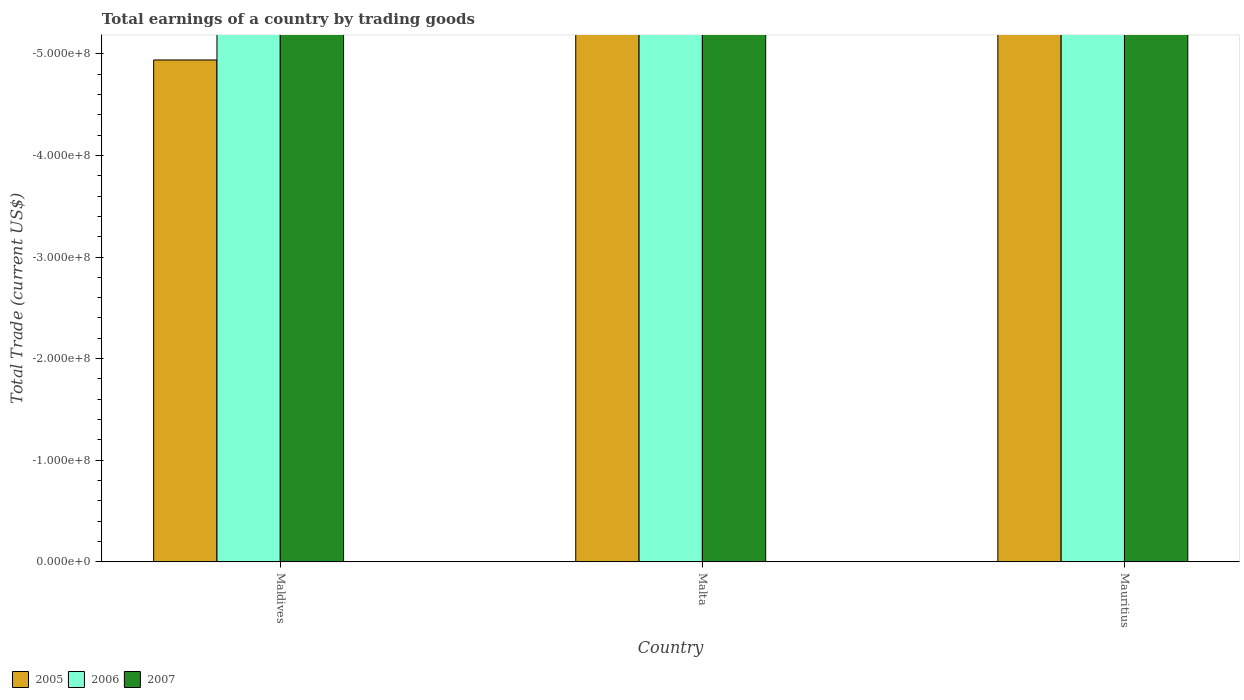Are the number of bars per tick equal to the number of legend labels?
Offer a very short reply. No. Are the number of bars on each tick of the X-axis equal?
Offer a terse response. Yes. What is the label of the 2nd group of bars from the left?
Ensure brevity in your answer.  Malta. What is the total earnings in 2005 in Malta?
Your response must be concise. 0. What is the total total earnings in 2005 in the graph?
Your response must be concise. 0. What is the average total earnings in 2006 per country?
Offer a very short reply. 0. In how many countries, is the total earnings in 2006 greater than -320000000 US$?
Your answer should be very brief. 0. In how many countries, is the total earnings in 2006 greater than the average total earnings in 2006 taken over all countries?
Make the answer very short. 0. Is it the case that in every country, the sum of the total earnings in 2007 and total earnings in 2005 is greater than the total earnings in 2006?
Your response must be concise. No. Are all the bars in the graph horizontal?
Offer a terse response. No. What is the difference between two consecutive major ticks on the Y-axis?
Offer a terse response. 1.00e+08. Are the values on the major ticks of Y-axis written in scientific E-notation?
Provide a short and direct response. Yes. Does the graph contain grids?
Keep it short and to the point. No. Where does the legend appear in the graph?
Keep it short and to the point. Bottom left. What is the title of the graph?
Provide a short and direct response. Total earnings of a country by trading goods. What is the label or title of the X-axis?
Provide a short and direct response. Country. What is the label or title of the Y-axis?
Provide a short and direct response. Total Trade (current US$). What is the Total Trade (current US$) of 2005 in Maldives?
Your response must be concise. 0. What is the Total Trade (current US$) of 2006 in Mauritius?
Provide a short and direct response. 0. What is the total Total Trade (current US$) in 2006 in the graph?
Your response must be concise. 0. What is the total Total Trade (current US$) of 2007 in the graph?
Your answer should be very brief. 0. What is the average Total Trade (current US$) of 2005 per country?
Make the answer very short. 0. What is the average Total Trade (current US$) of 2007 per country?
Offer a terse response. 0. 